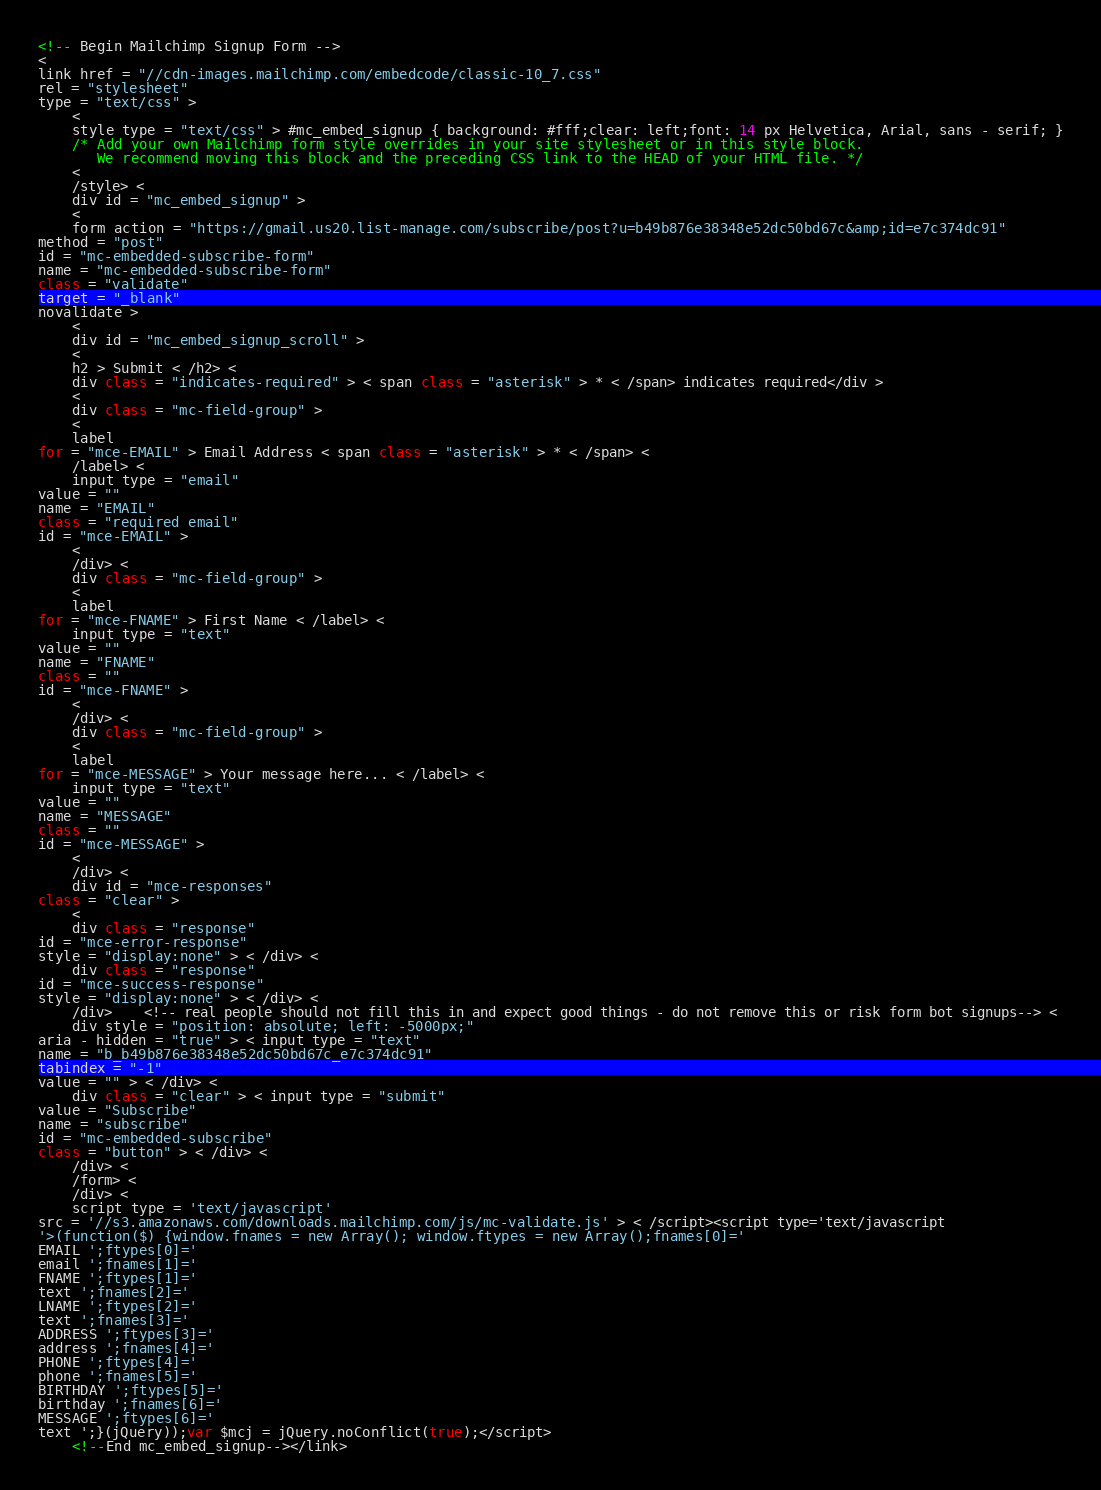<code> <loc_0><loc_0><loc_500><loc_500><_JavaScript_><!-- Begin Mailchimp Signup Form -->
<
link href = "//cdn-images.mailchimp.com/embedcode/classic-10_7.css"
rel = "stylesheet"
type = "text/css" >
    <
    style type = "text/css" > #mc_embed_signup { background: #fff;clear: left;font: 14 px Helvetica, Arial, sans - serif; }
    /* Add your own Mailchimp form style overrides in your site stylesheet or in this style block.
       We recommend moving this block and the preceding CSS link to the HEAD of your HTML file. */
    <
    /style> <
    div id = "mc_embed_signup" >
    <
    form action = "https://gmail.us20.list-manage.com/subscribe/post?u=b49b876e38348e52dc50bd67c&amp;id=e7c374dc91"
method = "post"
id = "mc-embedded-subscribe-form"
name = "mc-embedded-subscribe-form"
class = "validate"
target = "_blank"
novalidate >
    <
    div id = "mc_embed_signup_scroll" >
    <
    h2 > Submit < /h2> <
    div class = "indicates-required" > < span class = "asterisk" > * < /span> indicates required</div >
    <
    div class = "mc-field-group" >
    <
    label
for = "mce-EMAIL" > Email Address < span class = "asterisk" > * < /span> <
    /label> <
    input type = "email"
value = ""
name = "EMAIL"
class = "required email"
id = "mce-EMAIL" >
    <
    /div> <
    div class = "mc-field-group" >
    <
    label
for = "mce-FNAME" > First Name < /label> <
    input type = "text"
value = ""
name = "FNAME"
class = ""
id = "mce-FNAME" >
    <
    /div> <
    div class = "mc-field-group" >
    <
    label
for = "mce-MESSAGE" > Your message here... < /label> <
    input type = "text"
value = ""
name = "MESSAGE"
class = ""
id = "mce-MESSAGE" >
    <
    /div> <
    div id = "mce-responses"
class = "clear" >
    <
    div class = "response"
id = "mce-error-response"
style = "display:none" > < /div> <
    div class = "response"
id = "mce-success-response"
style = "display:none" > < /div> <
    /div>    <!-- real people should not fill this in and expect good things - do not remove this or risk form bot signups--> <
    div style = "position: absolute; left: -5000px;"
aria - hidden = "true" > < input type = "text"
name = "b_b49b876e38348e52dc50bd67c_e7c374dc91"
tabindex = "-1"
value = "" > < /div> <
    div class = "clear" > < input type = "submit"
value = "Subscribe"
name = "subscribe"
id = "mc-embedded-subscribe"
class = "button" > < /div> <
    /div> <
    /form> <
    /div> <
    script type = 'text/javascript'
src = '//s3.amazonaws.com/downloads.mailchimp.com/js/mc-validate.js' > < /script><script type='text/javascript
'>(function($) {window.fnames = new Array(); window.ftypes = new Array();fnames[0]='
EMAIL ';ftypes[0]='
email ';fnames[1]='
FNAME ';ftypes[1]='
text ';fnames[2]='
LNAME ';ftypes[2]='
text ';fnames[3]='
ADDRESS ';ftypes[3]='
address ';fnames[4]='
PHONE ';ftypes[4]='
phone ';fnames[5]='
BIRTHDAY ';ftypes[5]='
birthday ';fnames[6]='
MESSAGE ';ftypes[6]='
text ';}(jQuery));var $mcj = jQuery.noConflict(true);</script>
    <!--End mc_embed_signup--></link></code> 